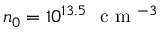<formula> <loc_0><loc_0><loc_500><loc_500>n _ { 0 } = 1 0 ^ { 1 3 . 5 } c m ^ { - 3 }</formula> 